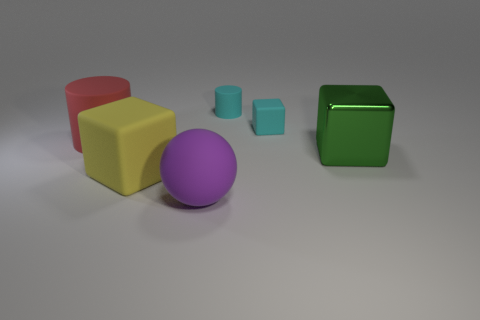What material is the big green object that is the same shape as the yellow rubber object?
Offer a terse response. Metal. What material is the green cube that is the same size as the red rubber thing?
Provide a short and direct response. Metal. How many objects are big cubes that are behind the big yellow object or cubes left of the big green metal thing?
Offer a terse response. 3. What is the object that is in front of the large cube left of the purple rubber ball that is left of the small cyan matte cylinder made of?
Ensure brevity in your answer.  Rubber. Does the cylinder that is right of the sphere have the same color as the tiny matte cube?
Offer a very short reply. Yes. What material is the big object that is both to the right of the large yellow thing and behind the purple rubber ball?
Make the answer very short. Metal. Are there any matte blocks of the same size as the red cylinder?
Keep it short and to the point. Yes. What number of gray matte cubes are there?
Ensure brevity in your answer.  0. How many tiny cyan rubber cubes are behind the big ball?
Provide a short and direct response. 1. Does the tiny cyan cylinder have the same material as the big cylinder?
Give a very brief answer. Yes. 